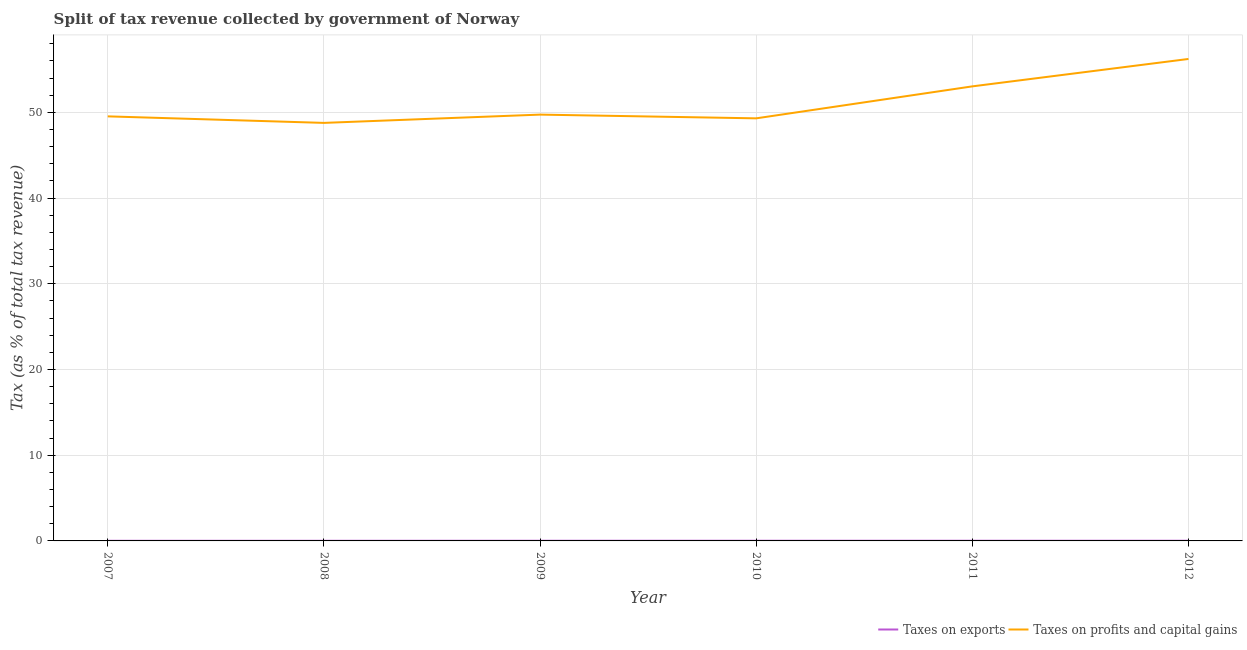What is the percentage of revenue obtained from taxes on exports in 2010?
Make the answer very short. 0.02. Across all years, what is the maximum percentage of revenue obtained from taxes on exports?
Provide a short and direct response. 0.02. Across all years, what is the minimum percentage of revenue obtained from taxes on exports?
Give a very brief answer. 0.02. In which year was the percentage of revenue obtained from taxes on profits and capital gains maximum?
Your response must be concise. 2012. What is the total percentage of revenue obtained from taxes on exports in the graph?
Provide a short and direct response. 0.12. What is the difference between the percentage of revenue obtained from taxes on exports in 2007 and that in 2008?
Your answer should be compact. 8.41393028672005e-5. What is the difference between the percentage of revenue obtained from taxes on profits and capital gains in 2007 and the percentage of revenue obtained from taxes on exports in 2011?
Your response must be concise. 49.5. What is the average percentage of revenue obtained from taxes on exports per year?
Give a very brief answer. 0.02. In the year 2011, what is the difference between the percentage of revenue obtained from taxes on exports and percentage of revenue obtained from taxes on profits and capital gains?
Give a very brief answer. -53. What is the ratio of the percentage of revenue obtained from taxes on exports in 2009 to that in 2011?
Ensure brevity in your answer.  0.93. What is the difference between the highest and the second highest percentage of revenue obtained from taxes on exports?
Provide a succinct answer. 0. What is the difference between the highest and the lowest percentage of revenue obtained from taxes on exports?
Your response must be concise. 0.01. In how many years, is the percentage of revenue obtained from taxes on exports greater than the average percentage of revenue obtained from taxes on exports taken over all years?
Your response must be concise. 4. Is the sum of the percentage of revenue obtained from taxes on profits and capital gains in 2008 and 2010 greater than the maximum percentage of revenue obtained from taxes on exports across all years?
Give a very brief answer. Yes. Does the percentage of revenue obtained from taxes on profits and capital gains monotonically increase over the years?
Give a very brief answer. No. Are the values on the major ticks of Y-axis written in scientific E-notation?
Offer a very short reply. No. Does the graph contain any zero values?
Provide a short and direct response. No. Where does the legend appear in the graph?
Provide a succinct answer. Bottom right. How are the legend labels stacked?
Make the answer very short. Horizontal. What is the title of the graph?
Provide a short and direct response. Split of tax revenue collected by government of Norway. What is the label or title of the X-axis?
Your response must be concise. Year. What is the label or title of the Y-axis?
Offer a very short reply. Tax (as % of total tax revenue). What is the Tax (as % of total tax revenue) of Taxes on exports in 2007?
Keep it short and to the point. 0.02. What is the Tax (as % of total tax revenue) of Taxes on profits and capital gains in 2007?
Ensure brevity in your answer.  49.53. What is the Tax (as % of total tax revenue) in Taxes on exports in 2008?
Offer a terse response. 0.02. What is the Tax (as % of total tax revenue) in Taxes on profits and capital gains in 2008?
Ensure brevity in your answer.  48.76. What is the Tax (as % of total tax revenue) in Taxes on exports in 2009?
Your response must be concise. 0.02. What is the Tax (as % of total tax revenue) in Taxes on profits and capital gains in 2009?
Offer a very short reply. 49.73. What is the Tax (as % of total tax revenue) in Taxes on exports in 2010?
Keep it short and to the point. 0.02. What is the Tax (as % of total tax revenue) of Taxes on profits and capital gains in 2010?
Provide a succinct answer. 49.3. What is the Tax (as % of total tax revenue) in Taxes on exports in 2011?
Make the answer very short. 0.02. What is the Tax (as % of total tax revenue) of Taxes on profits and capital gains in 2011?
Ensure brevity in your answer.  53.03. What is the Tax (as % of total tax revenue) of Taxes on exports in 2012?
Offer a very short reply. 0.02. What is the Tax (as % of total tax revenue) of Taxes on profits and capital gains in 2012?
Offer a terse response. 56.22. Across all years, what is the maximum Tax (as % of total tax revenue) in Taxes on exports?
Provide a succinct answer. 0.02. Across all years, what is the maximum Tax (as % of total tax revenue) of Taxes on profits and capital gains?
Your answer should be very brief. 56.22. Across all years, what is the minimum Tax (as % of total tax revenue) in Taxes on exports?
Provide a short and direct response. 0.02. Across all years, what is the minimum Tax (as % of total tax revenue) of Taxes on profits and capital gains?
Provide a succinct answer. 48.76. What is the total Tax (as % of total tax revenue) of Taxes on exports in the graph?
Your answer should be compact. 0.12. What is the total Tax (as % of total tax revenue) in Taxes on profits and capital gains in the graph?
Your answer should be very brief. 306.57. What is the difference between the Tax (as % of total tax revenue) in Taxes on profits and capital gains in 2007 and that in 2008?
Offer a very short reply. 0.76. What is the difference between the Tax (as % of total tax revenue) in Taxes on exports in 2007 and that in 2009?
Make the answer very short. -0. What is the difference between the Tax (as % of total tax revenue) of Taxes on profits and capital gains in 2007 and that in 2009?
Make the answer very short. -0.2. What is the difference between the Tax (as % of total tax revenue) of Taxes on exports in 2007 and that in 2010?
Provide a short and direct response. -0.01. What is the difference between the Tax (as % of total tax revenue) of Taxes on profits and capital gains in 2007 and that in 2010?
Your response must be concise. 0.23. What is the difference between the Tax (as % of total tax revenue) in Taxes on exports in 2007 and that in 2011?
Your answer should be very brief. -0.01. What is the difference between the Tax (as % of total tax revenue) of Taxes on profits and capital gains in 2007 and that in 2011?
Make the answer very short. -3.5. What is the difference between the Tax (as % of total tax revenue) of Taxes on exports in 2007 and that in 2012?
Your answer should be compact. -0. What is the difference between the Tax (as % of total tax revenue) in Taxes on profits and capital gains in 2007 and that in 2012?
Your answer should be compact. -6.7. What is the difference between the Tax (as % of total tax revenue) in Taxes on exports in 2008 and that in 2009?
Give a very brief answer. -0. What is the difference between the Tax (as % of total tax revenue) in Taxes on profits and capital gains in 2008 and that in 2009?
Keep it short and to the point. -0.97. What is the difference between the Tax (as % of total tax revenue) in Taxes on exports in 2008 and that in 2010?
Give a very brief answer. -0.01. What is the difference between the Tax (as % of total tax revenue) of Taxes on profits and capital gains in 2008 and that in 2010?
Offer a very short reply. -0.53. What is the difference between the Tax (as % of total tax revenue) of Taxes on exports in 2008 and that in 2011?
Your answer should be very brief. -0.01. What is the difference between the Tax (as % of total tax revenue) in Taxes on profits and capital gains in 2008 and that in 2011?
Ensure brevity in your answer.  -4.26. What is the difference between the Tax (as % of total tax revenue) of Taxes on exports in 2008 and that in 2012?
Your answer should be compact. -0. What is the difference between the Tax (as % of total tax revenue) in Taxes on profits and capital gains in 2008 and that in 2012?
Provide a short and direct response. -7.46. What is the difference between the Tax (as % of total tax revenue) in Taxes on exports in 2009 and that in 2010?
Give a very brief answer. -0. What is the difference between the Tax (as % of total tax revenue) in Taxes on profits and capital gains in 2009 and that in 2010?
Your response must be concise. 0.44. What is the difference between the Tax (as % of total tax revenue) in Taxes on exports in 2009 and that in 2011?
Keep it short and to the point. -0. What is the difference between the Tax (as % of total tax revenue) of Taxes on profits and capital gains in 2009 and that in 2011?
Offer a very short reply. -3.3. What is the difference between the Tax (as % of total tax revenue) in Taxes on exports in 2009 and that in 2012?
Offer a terse response. -0. What is the difference between the Tax (as % of total tax revenue) of Taxes on profits and capital gains in 2009 and that in 2012?
Keep it short and to the point. -6.49. What is the difference between the Tax (as % of total tax revenue) in Taxes on exports in 2010 and that in 2011?
Your answer should be compact. -0. What is the difference between the Tax (as % of total tax revenue) of Taxes on profits and capital gains in 2010 and that in 2011?
Give a very brief answer. -3.73. What is the difference between the Tax (as % of total tax revenue) in Taxes on exports in 2010 and that in 2012?
Your answer should be compact. 0. What is the difference between the Tax (as % of total tax revenue) in Taxes on profits and capital gains in 2010 and that in 2012?
Provide a succinct answer. -6.93. What is the difference between the Tax (as % of total tax revenue) in Taxes on exports in 2011 and that in 2012?
Offer a very short reply. 0. What is the difference between the Tax (as % of total tax revenue) of Taxes on profits and capital gains in 2011 and that in 2012?
Provide a succinct answer. -3.2. What is the difference between the Tax (as % of total tax revenue) of Taxes on exports in 2007 and the Tax (as % of total tax revenue) of Taxes on profits and capital gains in 2008?
Keep it short and to the point. -48.75. What is the difference between the Tax (as % of total tax revenue) of Taxes on exports in 2007 and the Tax (as % of total tax revenue) of Taxes on profits and capital gains in 2009?
Provide a succinct answer. -49.71. What is the difference between the Tax (as % of total tax revenue) of Taxes on exports in 2007 and the Tax (as % of total tax revenue) of Taxes on profits and capital gains in 2010?
Ensure brevity in your answer.  -49.28. What is the difference between the Tax (as % of total tax revenue) in Taxes on exports in 2007 and the Tax (as % of total tax revenue) in Taxes on profits and capital gains in 2011?
Provide a short and direct response. -53.01. What is the difference between the Tax (as % of total tax revenue) of Taxes on exports in 2007 and the Tax (as % of total tax revenue) of Taxes on profits and capital gains in 2012?
Provide a succinct answer. -56.21. What is the difference between the Tax (as % of total tax revenue) in Taxes on exports in 2008 and the Tax (as % of total tax revenue) in Taxes on profits and capital gains in 2009?
Offer a very short reply. -49.71. What is the difference between the Tax (as % of total tax revenue) of Taxes on exports in 2008 and the Tax (as % of total tax revenue) of Taxes on profits and capital gains in 2010?
Your answer should be very brief. -49.28. What is the difference between the Tax (as % of total tax revenue) of Taxes on exports in 2008 and the Tax (as % of total tax revenue) of Taxes on profits and capital gains in 2011?
Offer a terse response. -53.01. What is the difference between the Tax (as % of total tax revenue) in Taxes on exports in 2008 and the Tax (as % of total tax revenue) in Taxes on profits and capital gains in 2012?
Ensure brevity in your answer.  -56.21. What is the difference between the Tax (as % of total tax revenue) in Taxes on exports in 2009 and the Tax (as % of total tax revenue) in Taxes on profits and capital gains in 2010?
Ensure brevity in your answer.  -49.27. What is the difference between the Tax (as % of total tax revenue) in Taxes on exports in 2009 and the Tax (as % of total tax revenue) in Taxes on profits and capital gains in 2011?
Your answer should be compact. -53.01. What is the difference between the Tax (as % of total tax revenue) in Taxes on exports in 2009 and the Tax (as % of total tax revenue) in Taxes on profits and capital gains in 2012?
Keep it short and to the point. -56.2. What is the difference between the Tax (as % of total tax revenue) of Taxes on exports in 2010 and the Tax (as % of total tax revenue) of Taxes on profits and capital gains in 2011?
Keep it short and to the point. -53. What is the difference between the Tax (as % of total tax revenue) of Taxes on exports in 2010 and the Tax (as % of total tax revenue) of Taxes on profits and capital gains in 2012?
Your response must be concise. -56.2. What is the difference between the Tax (as % of total tax revenue) in Taxes on exports in 2011 and the Tax (as % of total tax revenue) in Taxes on profits and capital gains in 2012?
Give a very brief answer. -56.2. What is the average Tax (as % of total tax revenue) of Taxes on exports per year?
Give a very brief answer. 0.02. What is the average Tax (as % of total tax revenue) of Taxes on profits and capital gains per year?
Offer a terse response. 51.09. In the year 2007, what is the difference between the Tax (as % of total tax revenue) of Taxes on exports and Tax (as % of total tax revenue) of Taxes on profits and capital gains?
Make the answer very short. -49.51. In the year 2008, what is the difference between the Tax (as % of total tax revenue) in Taxes on exports and Tax (as % of total tax revenue) in Taxes on profits and capital gains?
Your answer should be compact. -48.75. In the year 2009, what is the difference between the Tax (as % of total tax revenue) in Taxes on exports and Tax (as % of total tax revenue) in Taxes on profits and capital gains?
Keep it short and to the point. -49.71. In the year 2010, what is the difference between the Tax (as % of total tax revenue) in Taxes on exports and Tax (as % of total tax revenue) in Taxes on profits and capital gains?
Make the answer very short. -49.27. In the year 2011, what is the difference between the Tax (as % of total tax revenue) in Taxes on exports and Tax (as % of total tax revenue) in Taxes on profits and capital gains?
Ensure brevity in your answer.  -53. In the year 2012, what is the difference between the Tax (as % of total tax revenue) of Taxes on exports and Tax (as % of total tax revenue) of Taxes on profits and capital gains?
Provide a short and direct response. -56.2. What is the ratio of the Tax (as % of total tax revenue) in Taxes on exports in 2007 to that in 2008?
Give a very brief answer. 1.01. What is the ratio of the Tax (as % of total tax revenue) of Taxes on profits and capital gains in 2007 to that in 2008?
Your answer should be very brief. 1.02. What is the ratio of the Tax (as % of total tax revenue) of Taxes on exports in 2007 to that in 2009?
Keep it short and to the point. 0.8. What is the ratio of the Tax (as % of total tax revenue) of Taxes on profits and capital gains in 2007 to that in 2009?
Ensure brevity in your answer.  1. What is the ratio of the Tax (as % of total tax revenue) of Taxes on exports in 2007 to that in 2010?
Ensure brevity in your answer.  0.77. What is the ratio of the Tax (as % of total tax revenue) of Taxes on exports in 2007 to that in 2011?
Make the answer very short. 0.75. What is the ratio of the Tax (as % of total tax revenue) in Taxes on profits and capital gains in 2007 to that in 2011?
Offer a terse response. 0.93. What is the ratio of the Tax (as % of total tax revenue) of Taxes on exports in 2007 to that in 2012?
Provide a short and direct response. 0.78. What is the ratio of the Tax (as % of total tax revenue) in Taxes on profits and capital gains in 2007 to that in 2012?
Keep it short and to the point. 0.88. What is the ratio of the Tax (as % of total tax revenue) of Taxes on exports in 2008 to that in 2009?
Offer a terse response. 0.8. What is the ratio of the Tax (as % of total tax revenue) in Taxes on profits and capital gains in 2008 to that in 2009?
Ensure brevity in your answer.  0.98. What is the ratio of the Tax (as % of total tax revenue) of Taxes on exports in 2008 to that in 2010?
Offer a terse response. 0.77. What is the ratio of the Tax (as % of total tax revenue) in Taxes on exports in 2008 to that in 2011?
Ensure brevity in your answer.  0.75. What is the ratio of the Tax (as % of total tax revenue) in Taxes on profits and capital gains in 2008 to that in 2011?
Your response must be concise. 0.92. What is the ratio of the Tax (as % of total tax revenue) of Taxes on exports in 2008 to that in 2012?
Keep it short and to the point. 0.77. What is the ratio of the Tax (as % of total tax revenue) of Taxes on profits and capital gains in 2008 to that in 2012?
Keep it short and to the point. 0.87. What is the ratio of the Tax (as % of total tax revenue) in Taxes on exports in 2009 to that in 2010?
Offer a terse response. 0.96. What is the ratio of the Tax (as % of total tax revenue) in Taxes on profits and capital gains in 2009 to that in 2010?
Offer a terse response. 1.01. What is the ratio of the Tax (as % of total tax revenue) in Taxes on exports in 2009 to that in 2011?
Provide a succinct answer. 0.93. What is the ratio of the Tax (as % of total tax revenue) of Taxes on profits and capital gains in 2009 to that in 2011?
Your response must be concise. 0.94. What is the ratio of the Tax (as % of total tax revenue) in Taxes on exports in 2009 to that in 2012?
Your answer should be compact. 0.97. What is the ratio of the Tax (as % of total tax revenue) in Taxes on profits and capital gains in 2009 to that in 2012?
Your answer should be compact. 0.88. What is the ratio of the Tax (as % of total tax revenue) of Taxes on exports in 2010 to that in 2011?
Provide a short and direct response. 0.97. What is the ratio of the Tax (as % of total tax revenue) in Taxes on profits and capital gains in 2010 to that in 2011?
Provide a succinct answer. 0.93. What is the ratio of the Tax (as % of total tax revenue) in Taxes on exports in 2010 to that in 2012?
Ensure brevity in your answer.  1.01. What is the ratio of the Tax (as % of total tax revenue) in Taxes on profits and capital gains in 2010 to that in 2012?
Make the answer very short. 0.88. What is the ratio of the Tax (as % of total tax revenue) in Taxes on exports in 2011 to that in 2012?
Give a very brief answer. 1.04. What is the ratio of the Tax (as % of total tax revenue) in Taxes on profits and capital gains in 2011 to that in 2012?
Ensure brevity in your answer.  0.94. What is the difference between the highest and the second highest Tax (as % of total tax revenue) of Taxes on exports?
Offer a terse response. 0. What is the difference between the highest and the second highest Tax (as % of total tax revenue) in Taxes on profits and capital gains?
Give a very brief answer. 3.2. What is the difference between the highest and the lowest Tax (as % of total tax revenue) in Taxes on exports?
Make the answer very short. 0.01. What is the difference between the highest and the lowest Tax (as % of total tax revenue) in Taxes on profits and capital gains?
Your answer should be very brief. 7.46. 